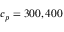Convert formula to latex. <formula><loc_0><loc_0><loc_500><loc_500>c _ { p } = 3 0 0 , 4 0 0</formula> 